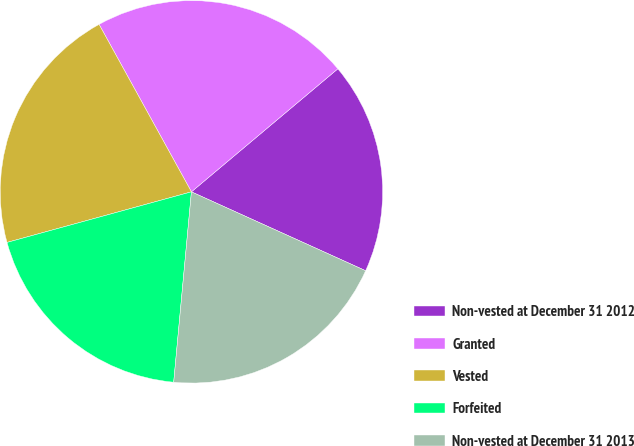Convert chart. <chart><loc_0><loc_0><loc_500><loc_500><pie_chart><fcel>Non-vested at December 31 2012<fcel>Granted<fcel>Vested<fcel>Forfeited<fcel>Non-vested at December 31 2013<nl><fcel>17.89%<fcel>21.9%<fcel>21.24%<fcel>19.26%<fcel>19.71%<nl></chart> 